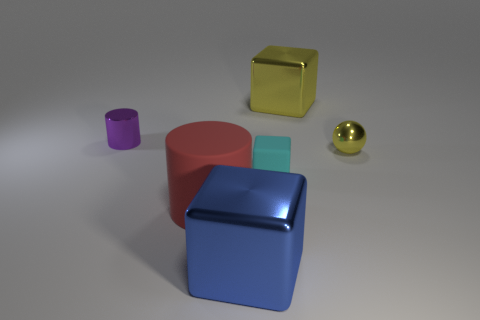Subtract all purple cylinders. How many cylinders are left? 1 Subtract all cyan matte cubes. How many cubes are left? 2 Subtract all spheres. How many objects are left? 5 Subtract 1 cylinders. How many cylinders are left? 1 Add 3 blue rubber things. How many blue rubber things exist? 3 Add 2 small cyan blocks. How many objects exist? 8 Subtract 1 purple cylinders. How many objects are left? 5 Subtract all gray spheres. Subtract all green blocks. How many spheres are left? 1 Subtract all brown cylinders. How many cyan blocks are left? 1 Subtract all big yellow cubes. Subtract all large gray balls. How many objects are left? 5 